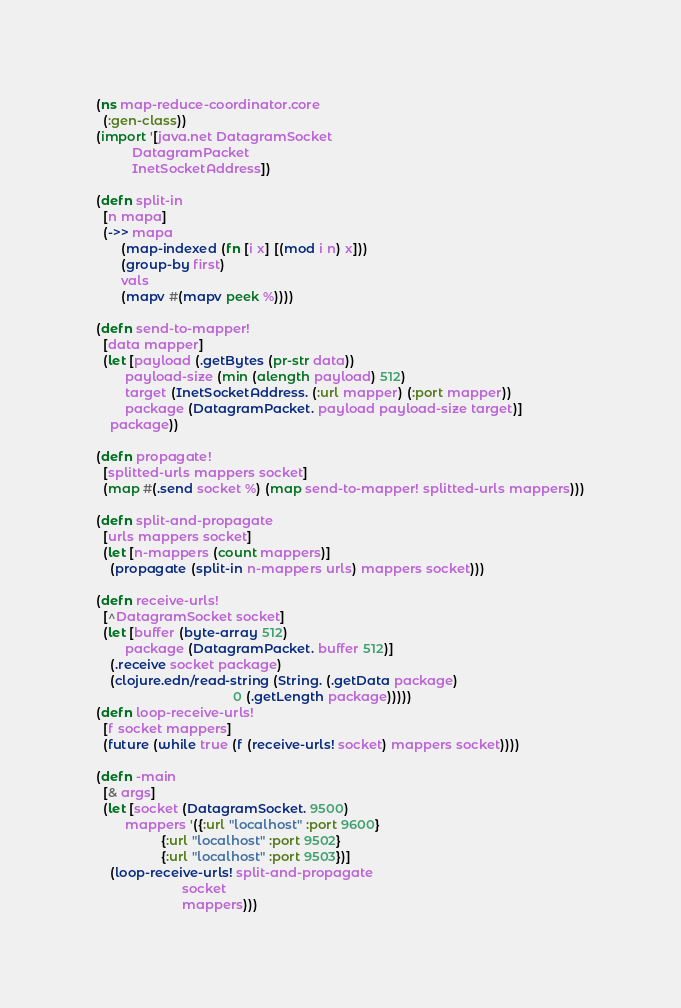Convert code to text. <code><loc_0><loc_0><loc_500><loc_500><_Clojure_>(ns map-reduce-coordinator.core
  (:gen-class))
(import '[java.net DatagramSocket
          DatagramPacket
          InetSocketAddress])

(defn split-in
  [n mapa]
  (->> mapa
       (map-indexed (fn [i x] [(mod i n) x]))
       (group-by first)
       vals
       (mapv #(mapv peek %))))

(defn send-to-mapper!
  [data mapper]
  (let [payload (.getBytes (pr-str data))
        payload-size (min (alength payload) 512)
        target (InetSocketAddress. (:url mapper) (:port mapper))
        package (DatagramPacket. payload payload-size target)]
    package))

(defn propagate!
  [splitted-urls mappers socket]
  (map #(.send socket %) (map send-to-mapper! splitted-urls mappers)))

(defn split-and-propagate
  [urls mappers socket]
  (let [n-mappers (count mappers)]
    (propagate (split-in n-mappers urls) mappers socket)))

(defn receive-urls!
  [^DatagramSocket socket]
  (let [buffer (byte-array 512)
        package (DatagramPacket. buffer 512)]
    (.receive socket package)
    (clojure.edn/read-string (String. (.getData package)
                                      0 (.getLength package)))))
(defn loop-receive-urls!
  [f socket mappers]
  (future (while true (f (receive-urls! socket) mappers socket))))

(defn -main
  [& args]
  (let [socket (DatagramSocket. 9500)
        mappers '({:url "localhost" :port 9600}
                  {:url "localhost" :port 9502}
                  {:url "localhost" :port 9503})]
    (loop-receive-urls! split-and-propagate
                        socket
                        mappers)))
</code> 